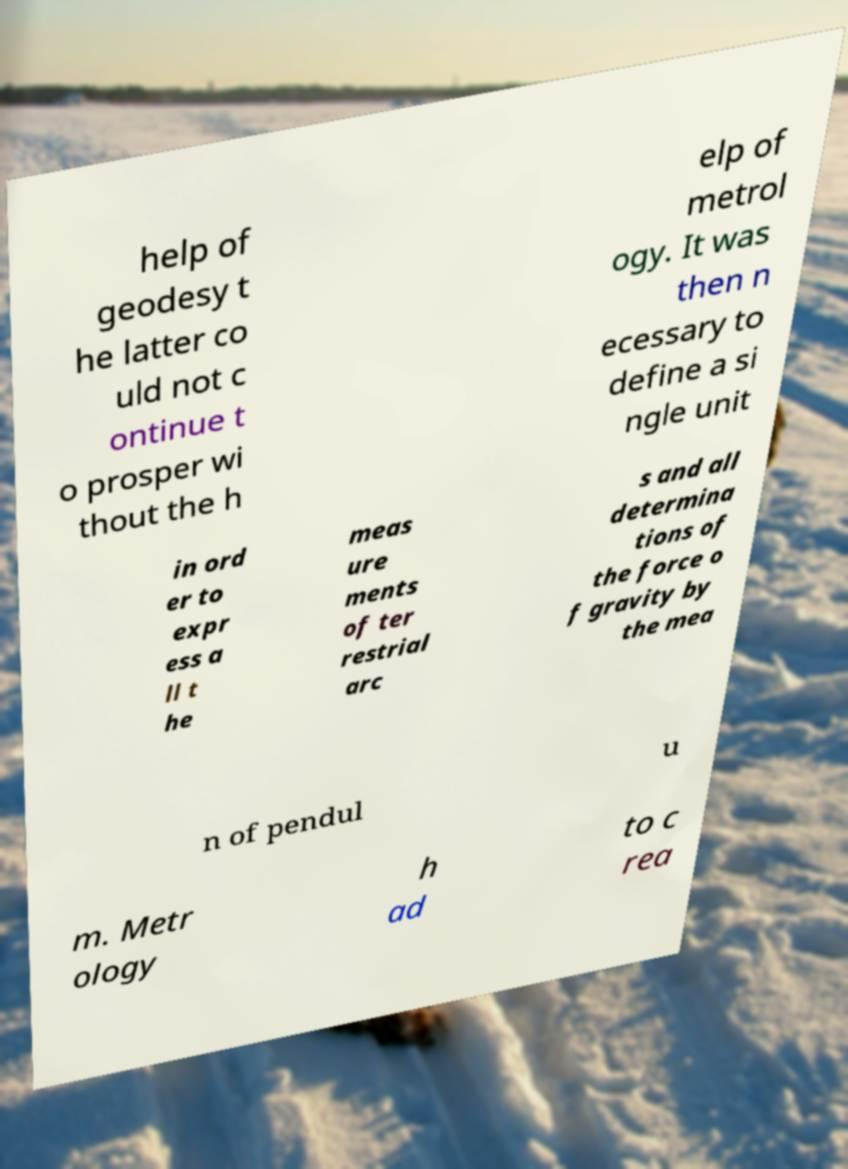I need the written content from this picture converted into text. Can you do that? help of geodesy t he latter co uld not c ontinue t o prosper wi thout the h elp of metrol ogy. It was then n ecessary to define a si ngle unit in ord er to expr ess a ll t he meas ure ments of ter restrial arc s and all determina tions of the force o f gravity by the mea n of pendul u m. Metr ology h ad to c rea 